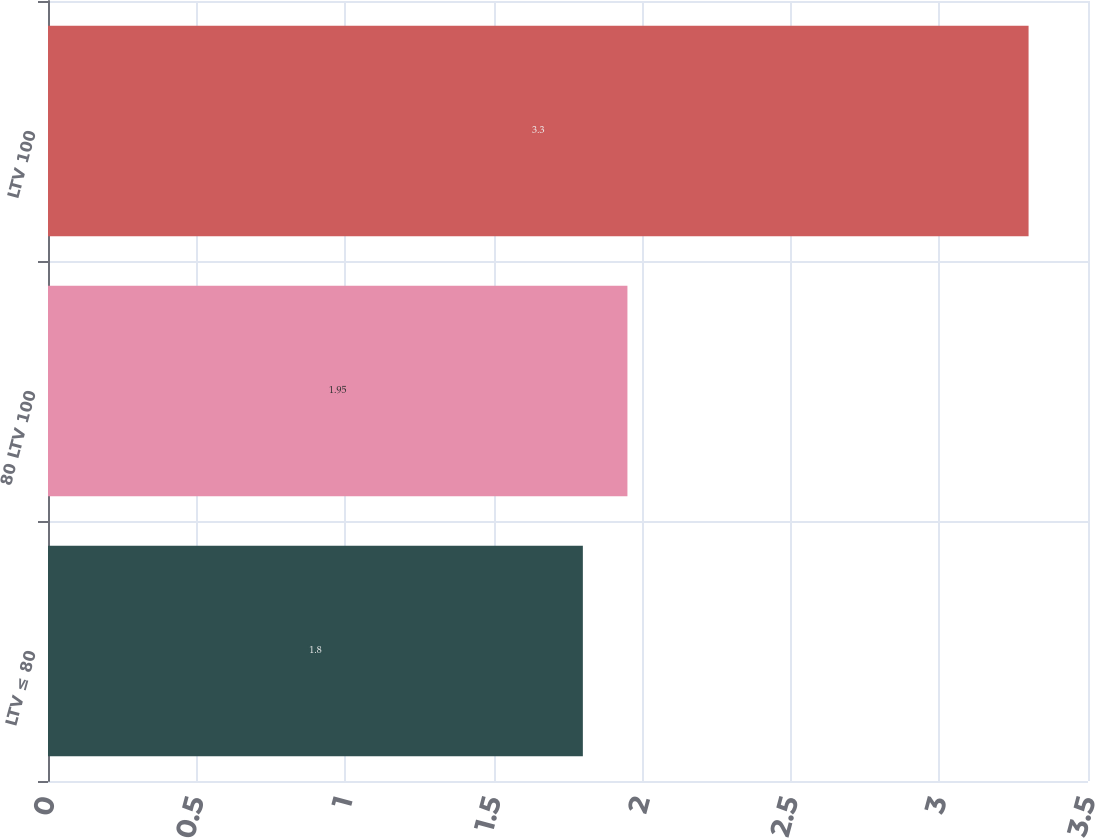<chart> <loc_0><loc_0><loc_500><loc_500><bar_chart><fcel>LTV ≤ 80<fcel>80 LTV 100<fcel>LTV 100<nl><fcel>1.8<fcel>1.95<fcel>3.3<nl></chart> 